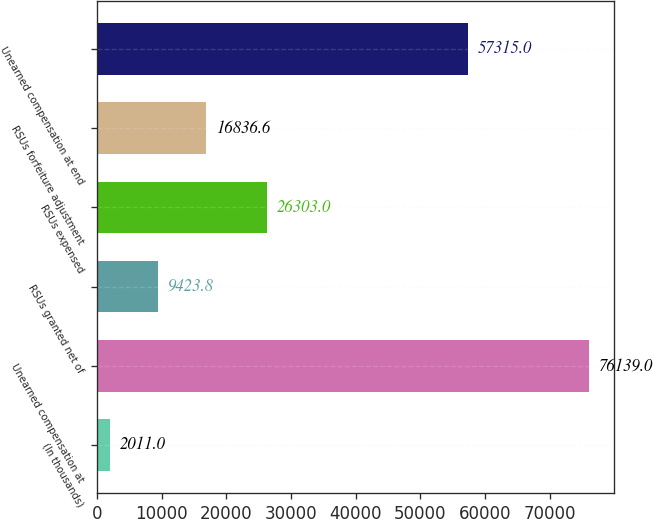Convert chart. <chart><loc_0><loc_0><loc_500><loc_500><bar_chart><fcel>(In thousands)<fcel>Unearned compensation at<fcel>RSUs granted net of<fcel>RSUs expensed<fcel>RSUs forfeiture adjustment<fcel>Unearned compensation at end<nl><fcel>2011<fcel>76139<fcel>9423.8<fcel>26303<fcel>16836.6<fcel>57315<nl></chart> 